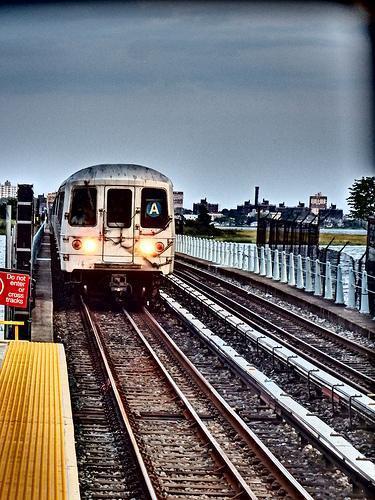How many trains is there?
Give a very brief answer. 1. 